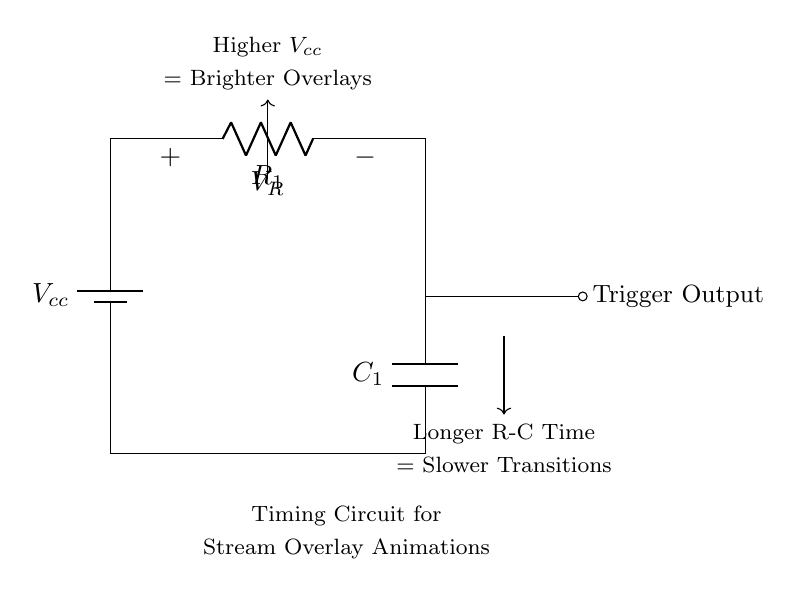What type of circuit is this? The circuit is a timing circuit, specifically a resistor-capacitor or RC circuit, used for controlling time delays in animations and transitions.
Answer: timing circuit What component is labeled C1? The component labeled C1 is a capacitor, which stores electrical energy temporarily and influences the timing behavior of the circuit.
Answer: capacitor What happens when you increase R1? Increasing R1 will result in a longer time constant for the circuit, which means slower transitions in animations.
Answer: slower transitions What effect does a higher Vcc have on the overlay? A higher Vcc increases the voltage across the connected elements, resulting in brighter overlays for the stream.
Answer: brighter overlays What is the role of the battery in this circuit? The battery provides the necessary voltage (Vcc) that powers the circuit, allowing the current to flow through R1 and C1.
Answer: power supply 